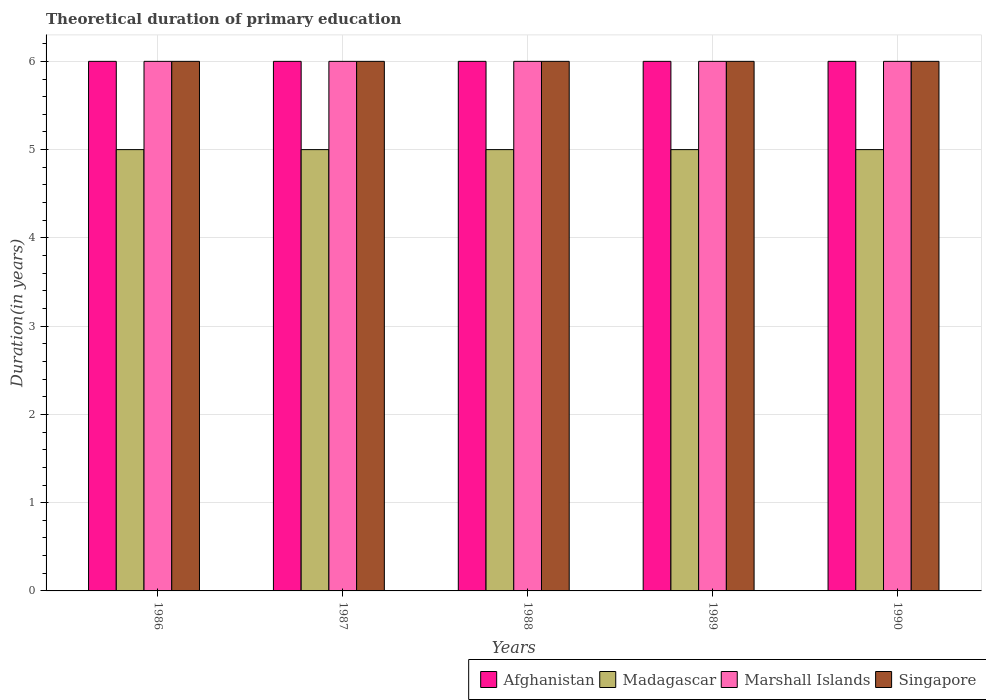How many different coloured bars are there?
Give a very brief answer. 4. Are the number of bars on each tick of the X-axis equal?
Your response must be concise. Yes. What is the total theoretical duration of primary education in Madagascar in 1990?
Keep it short and to the point. 5. Across all years, what is the maximum total theoretical duration of primary education in Afghanistan?
Make the answer very short. 6. In which year was the total theoretical duration of primary education in Afghanistan maximum?
Make the answer very short. 1986. In which year was the total theoretical duration of primary education in Singapore minimum?
Provide a short and direct response. 1986. What is the total total theoretical duration of primary education in Singapore in the graph?
Keep it short and to the point. 30. In the year 1987, what is the difference between the total theoretical duration of primary education in Afghanistan and total theoretical duration of primary education in Madagascar?
Provide a succinct answer. 1. Is the total theoretical duration of primary education in Afghanistan in 1986 less than that in 1990?
Provide a succinct answer. No. What is the difference between the highest and the second highest total theoretical duration of primary education in Afghanistan?
Provide a succinct answer. 0. In how many years, is the total theoretical duration of primary education in Madagascar greater than the average total theoretical duration of primary education in Madagascar taken over all years?
Your answer should be compact. 0. What does the 3rd bar from the left in 1986 represents?
Your answer should be compact. Marshall Islands. What does the 3rd bar from the right in 1987 represents?
Offer a terse response. Madagascar. Is it the case that in every year, the sum of the total theoretical duration of primary education in Singapore and total theoretical duration of primary education in Marshall Islands is greater than the total theoretical duration of primary education in Afghanistan?
Offer a very short reply. Yes. Are all the bars in the graph horizontal?
Ensure brevity in your answer.  No. What is the difference between two consecutive major ticks on the Y-axis?
Keep it short and to the point. 1. Are the values on the major ticks of Y-axis written in scientific E-notation?
Provide a succinct answer. No. How many legend labels are there?
Your response must be concise. 4. How are the legend labels stacked?
Provide a succinct answer. Horizontal. What is the title of the graph?
Offer a terse response. Theoretical duration of primary education. What is the label or title of the X-axis?
Provide a short and direct response. Years. What is the label or title of the Y-axis?
Provide a succinct answer. Duration(in years). What is the Duration(in years) of Afghanistan in 1986?
Keep it short and to the point. 6. What is the Duration(in years) in Afghanistan in 1987?
Provide a short and direct response. 6. What is the Duration(in years) of Afghanistan in 1988?
Provide a short and direct response. 6. What is the Duration(in years) in Marshall Islands in 1988?
Your answer should be compact. 6. What is the Duration(in years) in Afghanistan in 1990?
Your answer should be very brief. 6. What is the Duration(in years) of Madagascar in 1990?
Make the answer very short. 5. Across all years, what is the maximum Duration(in years) in Afghanistan?
Provide a succinct answer. 6. Across all years, what is the maximum Duration(in years) in Madagascar?
Provide a short and direct response. 5. Across all years, what is the maximum Duration(in years) of Singapore?
Make the answer very short. 6. Across all years, what is the minimum Duration(in years) of Madagascar?
Give a very brief answer. 5. Across all years, what is the minimum Duration(in years) in Marshall Islands?
Keep it short and to the point. 6. What is the total Duration(in years) of Madagascar in the graph?
Your response must be concise. 25. What is the total Duration(in years) of Singapore in the graph?
Keep it short and to the point. 30. What is the difference between the Duration(in years) of Marshall Islands in 1986 and that in 1987?
Your answer should be very brief. 0. What is the difference between the Duration(in years) of Singapore in 1986 and that in 1987?
Give a very brief answer. 0. What is the difference between the Duration(in years) of Singapore in 1986 and that in 1988?
Give a very brief answer. 0. What is the difference between the Duration(in years) of Madagascar in 1986 and that in 1989?
Offer a terse response. 0. What is the difference between the Duration(in years) of Afghanistan in 1986 and that in 1990?
Ensure brevity in your answer.  0. What is the difference between the Duration(in years) of Madagascar in 1986 and that in 1990?
Make the answer very short. 0. What is the difference between the Duration(in years) in Singapore in 1986 and that in 1990?
Make the answer very short. 0. What is the difference between the Duration(in years) in Afghanistan in 1987 and that in 1988?
Make the answer very short. 0. What is the difference between the Duration(in years) in Madagascar in 1987 and that in 1989?
Your response must be concise. 0. What is the difference between the Duration(in years) of Afghanistan in 1987 and that in 1990?
Offer a very short reply. 0. What is the difference between the Duration(in years) of Madagascar in 1987 and that in 1990?
Offer a very short reply. 0. What is the difference between the Duration(in years) of Marshall Islands in 1987 and that in 1990?
Offer a terse response. 0. What is the difference between the Duration(in years) in Singapore in 1987 and that in 1990?
Your response must be concise. 0. What is the difference between the Duration(in years) in Afghanistan in 1988 and that in 1989?
Give a very brief answer. 0. What is the difference between the Duration(in years) of Singapore in 1988 and that in 1989?
Provide a succinct answer. 0. What is the difference between the Duration(in years) in Afghanistan in 1988 and that in 1990?
Your answer should be very brief. 0. What is the difference between the Duration(in years) in Marshall Islands in 1988 and that in 1990?
Your response must be concise. 0. What is the difference between the Duration(in years) of Afghanistan in 1989 and that in 1990?
Ensure brevity in your answer.  0. What is the difference between the Duration(in years) of Marshall Islands in 1989 and that in 1990?
Your answer should be compact. 0. What is the difference between the Duration(in years) of Singapore in 1989 and that in 1990?
Ensure brevity in your answer.  0. What is the difference between the Duration(in years) in Afghanistan in 1986 and the Duration(in years) in Marshall Islands in 1987?
Offer a terse response. 0. What is the difference between the Duration(in years) of Afghanistan in 1986 and the Duration(in years) of Madagascar in 1988?
Provide a succinct answer. 1. What is the difference between the Duration(in years) of Afghanistan in 1986 and the Duration(in years) of Marshall Islands in 1988?
Keep it short and to the point. 0. What is the difference between the Duration(in years) of Afghanistan in 1986 and the Duration(in years) of Singapore in 1988?
Offer a very short reply. 0. What is the difference between the Duration(in years) in Afghanistan in 1986 and the Duration(in years) in Madagascar in 1989?
Keep it short and to the point. 1. What is the difference between the Duration(in years) of Afghanistan in 1986 and the Duration(in years) of Marshall Islands in 1989?
Your answer should be compact. 0. What is the difference between the Duration(in years) of Madagascar in 1986 and the Duration(in years) of Singapore in 1989?
Your answer should be compact. -1. What is the difference between the Duration(in years) of Marshall Islands in 1986 and the Duration(in years) of Singapore in 1989?
Make the answer very short. 0. What is the difference between the Duration(in years) of Afghanistan in 1986 and the Duration(in years) of Madagascar in 1990?
Your answer should be compact. 1. What is the difference between the Duration(in years) of Afghanistan in 1986 and the Duration(in years) of Marshall Islands in 1990?
Your answer should be compact. 0. What is the difference between the Duration(in years) in Madagascar in 1986 and the Duration(in years) in Singapore in 1990?
Provide a short and direct response. -1. What is the difference between the Duration(in years) in Madagascar in 1987 and the Duration(in years) in Singapore in 1988?
Keep it short and to the point. -1. What is the difference between the Duration(in years) in Marshall Islands in 1987 and the Duration(in years) in Singapore in 1988?
Give a very brief answer. 0. What is the difference between the Duration(in years) in Afghanistan in 1987 and the Duration(in years) in Madagascar in 1989?
Provide a short and direct response. 1. What is the difference between the Duration(in years) in Afghanistan in 1987 and the Duration(in years) in Marshall Islands in 1989?
Offer a terse response. 0. What is the difference between the Duration(in years) in Madagascar in 1987 and the Duration(in years) in Marshall Islands in 1989?
Provide a short and direct response. -1. What is the difference between the Duration(in years) of Madagascar in 1987 and the Duration(in years) of Singapore in 1989?
Provide a short and direct response. -1. What is the difference between the Duration(in years) in Afghanistan in 1987 and the Duration(in years) in Madagascar in 1990?
Your answer should be compact. 1. What is the difference between the Duration(in years) of Madagascar in 1987 and the Duration(in years) of Marshall Islands in 1990?
Give a very brief answer. -1. What is the difference between the Duration(in years) in Madagascar in 1987 and the Duration(in years) in Singapore in 1990?
Make the answer very short. -1. What is the difference between the Duration(in years) of Afghanistan in 1988 and the Duration(in years) of Madagascar in 1989?
Your answer should be compact. 1. What is the difference between the Duration(in years) in Marshall Islands in 1988 and the Duration(in years) in Singapore in 1989?
Your response must be concise. 0. What is the difference between the Duration(in years) in Afghanistan in 1988 and the Duration(in years) in Madagascar in 1990?
Give a very brief answer. 1. What is the difference between the Duration(in years) in Madagascar in 1988 and the Duration(in years) in Marshall Islands in 1990?
Your answer should be compact. -1. What is the difference between the Duration(in years) in Madagascar in 1988 and the Duration(in years) in Singapore in 1990?
Offer a very short reply. -1. What is the difference between the Duration(in years) of Afghanistan in 1989 and the Duration(in years) of Marshall Islands in 1990?
Make the answer very short. 0. What is the difference between the Duration(in years) of Afghanistan in 1989 and the Duration(in years) of Singapore in 1990?
Your response must be concise. 0. What is the difference between the Duration(in years) in Madagascar in 1989 and the Duration(in years) in Singapore in 1990?
Give a very brief answer. -1. What is the difference between the Duration(in years) of Marshall Islands in 1989 and the Duration(in years) of Singapore in 1990?
Keep it short and to the point. 0. In the year 1986, what is the difference between the Duration(in years) in Afghanistan and Duration(in years) in Madagascar?
Give a very brief answer. 1. In the year 1986, what is the difference between the Duration(in years) of Afghanistan and Duration(in years) of Marshall Islands?
Provide a short and direct response. 0. In the year 1986, what is the difference between the Duration(in years) of Afghanistan and Duration(in years) of Singapore?
Offer a terse response. 0. In the year 1986, what is the difference between the Duration(in years) in Madagascar and Duration(in years) in Marshall Islands?
Provide a succinct answer. -1. In the year 1988, what is the difference between the Duration(in years) in Afghanistan and Duration(in years) in Madagascar?
Offer a very short reply. 1. In the year 1988, what is the difference between the Duration(in years) of Madagascar and Duration(in years) of Marshall Islands?
Your response must be concise. -1. In the year 1988, what is the difference between the Duration(in years) in Madagascar and Duration(in years) in Singapore?
Your response must be concise. -1. In the year 1988, what is the difference between the Duration(in years) of Marshall Islands and Duration(in years) of Singapore?
Provide a short and direct response. 0. In the year 1989, what is the difference between the Duration(in years) of Afghanistan and Duration(in years) of Singapore?
Your answer should be compact. 0. In the year 1989, what is the difference between the Duration(in years) in Madagascar and Duration(in years) in Singapore?
Offer a very short reply. -1. In the year 1990, what is the difference between the Duration(in years) of Afghanistan and Duration(in years) of Marshall Islands?
Make the answer very short. 0. In the year 1990, what is the difference between the Duration(in years) of Madagascar and Duration(in years) of Marshall Islands?
Your answer should be compact. -1. In the year 1990, what is the difference between the Duration(in years) in Madagascar and Duration(in years) in Singapore?
Ensure brevity in your answer.  -1. In the year 1990, what is the difference between the Duration(in years) in Marshall Islands and Duration(in years) in Singapore?
Make the answer very short. 0. What is the ratio of the Duration(in years) in Singapore in 1986 to that in 1987?
Offer a terse response. 1. What is the ratio of the Duration(in years) in Afghanistan in 1986 to that in 1988?
Keep it short and to the point. 1. What is the ratio of the Duration(in years) in Marshall Islands in 1986 to that in 1988?
Offer a terse response. 1. What is the ratio of the Duration(in years) of Afghanistan in 1986 to that in 1989?
Make the answer very short. 1. What is the ratio of the Duration(in years) of Marshall Islands in 1986 to that in 1989?
Offer a very short reply. 1. What is the ratio of the Duration(in years) in Afghanistan in 1986 to that in 1990?
Your answer should be very brief. 1. What is the ratio of the Duration(in years) of Afghanistan in 1987 to that in 1988?
Offer a very short reply. 1. What is the ratio of the Duration(in years) of Singapore in 1987 to that in 1988?
Keep it short and to the point. 1. What is the ratio of the Duration(in years) of Afghanistan in 1987 to that in 1989?
Provide a short and direct response. 1. What is the ratio of the Duration(in years) in Marshall Islands in 1987 to that in 1989?
Make the answer very short. 1. What is the ratio of the Duration(in years) in Madagascar in 1987 to that in 1990?
Provide a succinct answer. 1. What is the ratio of the Duration(in years) in Madagascar in 1988 to that in 1989?
Offer a very short reply. 1. What is the ratio of the Duration(in years) of Madagascar in 1988 to that in 1990?
Your answer should be very brief. 1. What is the ratio of the Duration(in years) in Marshall Islands in 1988 to that in 1990?
Offer a terse response. 1. What is the ratio of the Duration(in years) of Madagascar in 1989 to that in 1990?
Offer a terse response. 1. What is the ratio of the Duration(in years) in Marshall Islands in 1989 to that in 1990?
Keep it short and to the point. 1. What is the ratio of the Duration(in years) of Singapore in 1989 to that in 1990?
Your answer should be compact. 1. What is the difference between the highest and the second highest Duration(in years) in Madagascar?
Ensure brevity in your answer.  0. What is the difference between the highest and the second highest Duration(in years) of Marshall Islands?
Give a very brief answer. 0. What is the difference between the highest and the lowest Duration(in years) in Afghanistan?
Give a very brief answer. 0. What is the difference between the highest and the lowest Duration(in years) in Madagascar?
Make the answer very short. 0. 